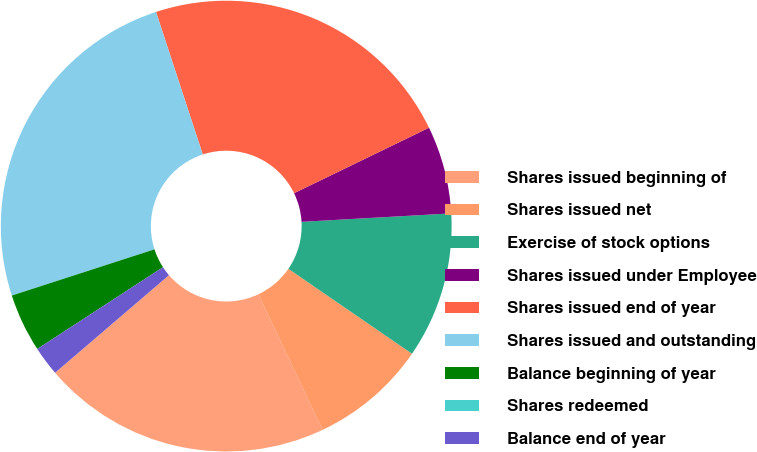<chart> <loc_0><loc_0><loc_500><loc_500><pie_chart><fcel>Shares issued beginning of<fcel>Shares issued net<fcel>Exercise of stock options<fcel>Shares issued under Employee<fcel>Shares issued end of year<fcel>Shares issued and outstanding<fcel>Balance beginning of year<fcel>Shares redeemed<fcel>Balance end of year<nl><fcel>20.75%<fcel>8.39%<fcel>10.48%<fcel>6.29%<fcel>22.85%<fcel>24.94%<fcel>4.19%<fcel>0.0%<fcel>2.1%<nl></chart> 